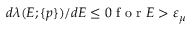Convert formula to latex. <formula><loc_0><loc_0><loc_500><loc_500>\begin{array} { r } { d \lambda ( E ; \{ p \} ) / d E \leq 0 f o r E > \varepsilon _ { \mu } } \end{array}</formula> 